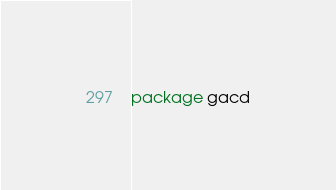Convert code to text. <code><loc_0><loc_0><loc_500><loc_500><_Go_>package gacd
</code> 